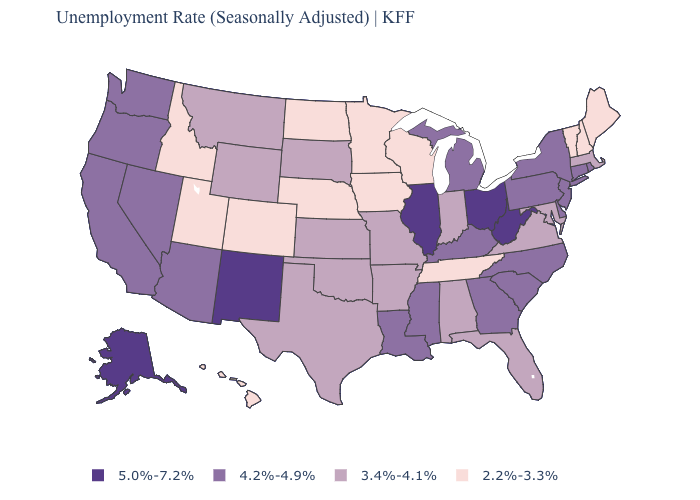What is the highest value in the South ?
Be succinct. 5.0%-7.2%. Name the states that have a value in the range 2.2%-3.3%?
Be succinct. Colorado, Hawaii, Idaho, Iowa, Maine, Minnesota, Nebraska, New Hampshire, North Dakota, Tennessee, Utah, Vermont, Wisconsin. What is the highest value in the USA?
Keep it brief. 5.0%-7.2%. Name the states that have a value in the range 2.2%-3.3%?
Write a very short answer. Colorado, Hawaii, Idaho, Iowa, Maine, Minnesota, Nebraska, New Hampshire, North Dakota, Tennessee, Utah, Vermont, Wisconsin. Does the map have missing data?
Be succinct. No. What is the value of Oklahoma?
Quick response, please. 3.4%-4.1%. What is the value of Tennessee?
Concise answer only. 2.2%-3.3%. Is the legend a continuous bar?
Keep it brief. No. Which states have the highest value in the USA?
Be succinct. Alaska, Illinois, New Mexico, Ohio, West Virginia. What is the lowest value in the South?
Give a very brief answer. 2.2%-3.3%. What is the value of New Mexico?
Write a very short answer. 5.0%-7.2%. Name the states that have a value in the range 4.2%-4.9%?
Be succinct. Arizona, California, Connecticut, Delaware, Georgia, Kentucky, Louisiana, Michigan, Mississippi, Nevada, New Jersey, New York, North Carolina, Oregon, Pennsylvania, Rhode Island, South Carolina, Washington. What is the value of Missouri?
Answer briefly. 3.4%-4.1%. Among the states that border Ohio , does Indiana have the lowest value?
Write a very short answer. Yes. 